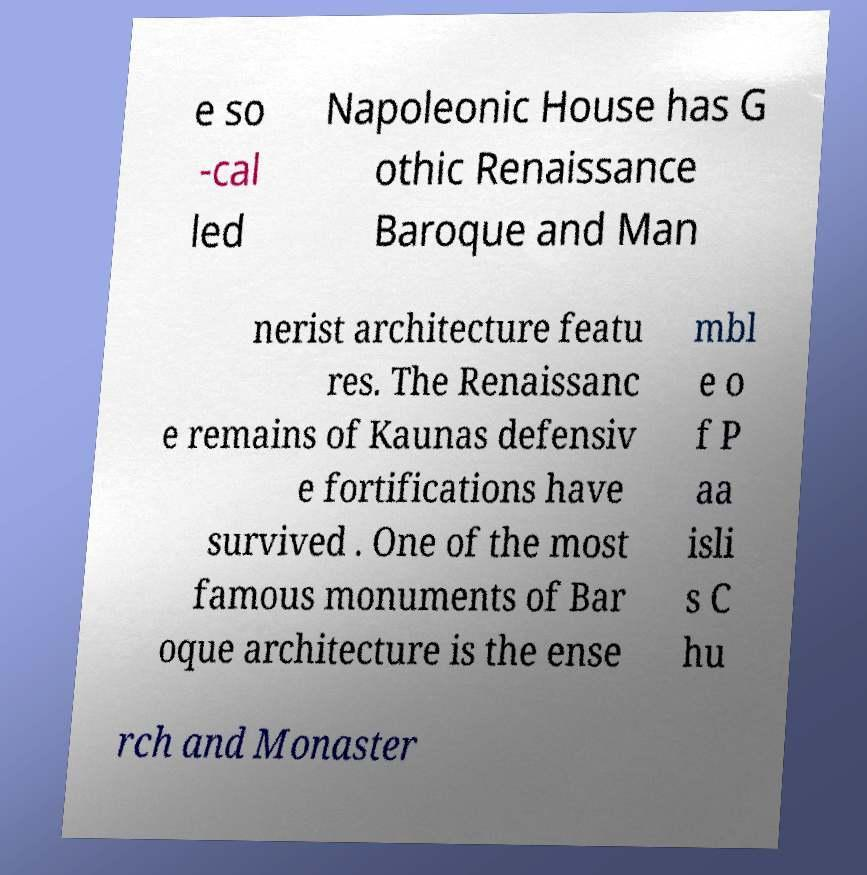What messages or text are displayed in this image? I need them in a readable, typed format. e so -cal led Napoleonic House has G othic Renaissance Baroque and Man nerist architecture featu res. The Renaissanc e remains of Kaunas defensiv e fortifications have survived . One of the most famous monuments of Bar oque architecture is the ense mbl e o f P aa isli s C hu rch and Monaster 